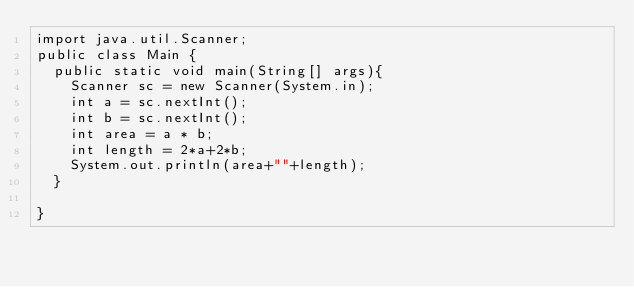<code> <loc_0><loc_0><loc_500><loc_500><_Java_>import java.util.Scanner;
public class Main {
	public static void main(String[] args){
		Scanner sc = new Scanner(System.in);
		int a = sc.nextInt();
		int b = sc.nextInt();
		int area = a * b;
		int length = 2*a+2*b;
		System.out.println(area+""+length);
	}

}</code> 